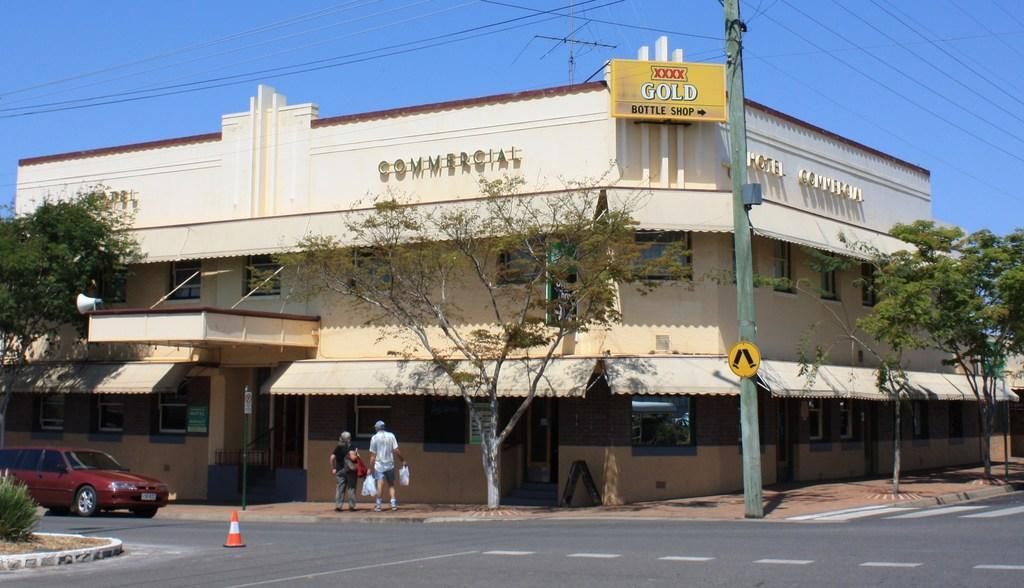How would you summarize this image in a sentence or two? There is a car on the road. Here we can see a traffic cone, plant, pole, trees, building, boards, and two persons. In the background there is sky. 